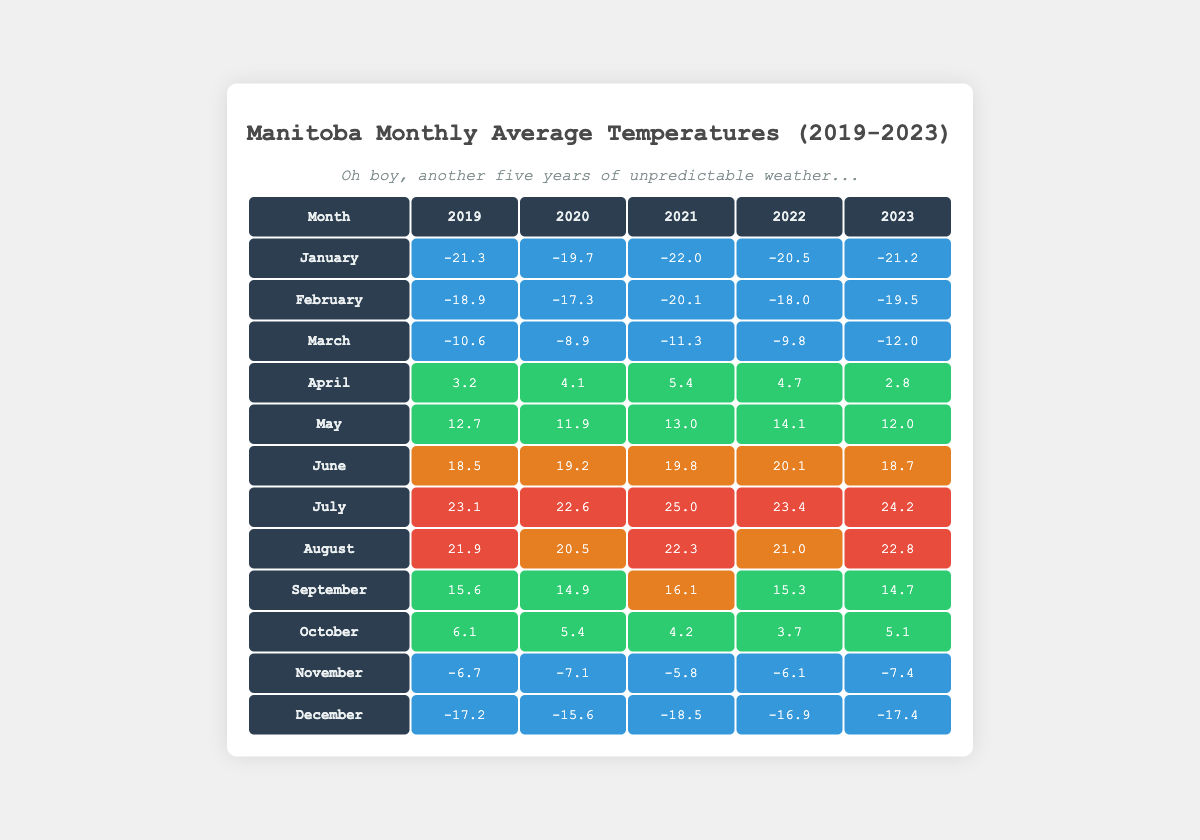What was the warmest month in Manitoba over the past five years? Reviewing the table, I can see that the warmest month for each year is July: 2019 (23.1), 2020 (22.6), 2021 (25.0), 2022 (23.4), and 2023 (24.2). The highest value among these is 25.0°C in July 2021.
Answer: 25.0°C Which year had the coldest January average temperature? Looking closely at the January values for each year, I see the following temperatures: 2019 (-21.3), 2020 (-19.7), 2021 (-22.0), 2022 (-20.5), and 2023 (-21.2). The lowest value occurs in January 2021, which is -22.0°C.
Answer: -22.0°C What is the average temperature for May over the five years? To find the average, I will sum the May temperatures: (12.7 + 11.9 + 13.0 + 14.1 + 12.0) = 63.7. Then, I will divide this sum by the number of years, which is 5: 63.7 / 5 = 12.74.
Answer: 12.74°C Is it true that November was colder than December in all years? Checking the temperatures for November and December: November had -6.7, -7.1, -5.8, -6.1, -7.4 while December had -17.2, -15.6, -18.5, -16.9, -17.4. In every case, November temperatures are warmer than December. Therefore, the statement is true.
Answer: Yes Which month in 2022 had the highest average temperature? Looking through each month's data for 2022, I see the following averages: January (-20.5), February (-18.0), March (-9.8), April (4.7), May (14.1), June (20.1), July (23.4), August (21.0), September (15.3), October (3.7), November (-6.1), December (-16.9). July has the highest temperature at 23.4°C.
Answer: July 